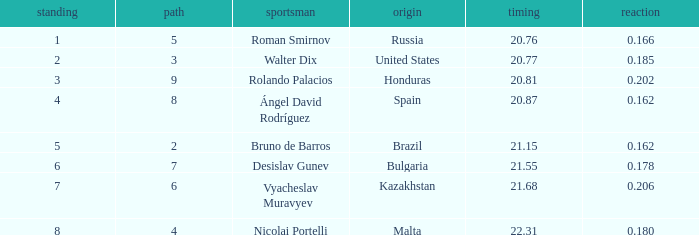What's Brazil's lane with a time less than 21.15? None. 